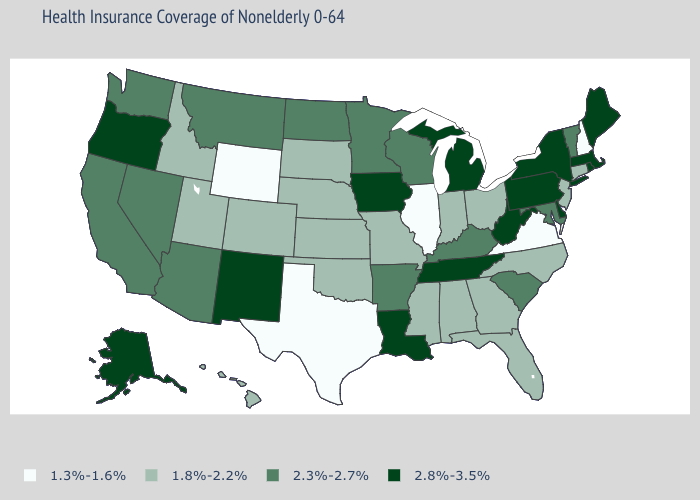Does the first symbol in the legend represent the smallest category?
Short answer required. Yes. What is the highest value in the South ?
Keep it brief. 2.8%-3.5%. Among the states that border New Hampshire , which have the highest value?
Quick response, please. Maine, Massachusetts. What is the value of Hawaii?
Give a very brief answer. 1.8%-2.2%. Is the legend a continuous bar?
Short answer required. No. Name the states that have a value in the range 2.3%-2.7%?
Be succinct. Arizona, Arkansas, California, Kentucky, Maryland, Minnesota, Montana, Nevada, North Dakota, South Carolina, Vermont, Washington, Wisconsin. Name the states that have a value in the range 2.8%-3.5%?
Concise answer only. Alaska, Delaware, Iowa, Louisiana, Maine, Massachusetts, Michigan, New Mexico, New York, Oregon, Pennsylvania, Rhode Island, Tennessee, West Virginia. Is the legend a continuous bar?
Quick response, please. No. What is the value of Missouri?
Answer briefly. 1.8%-2.2%. Does Utah have a higher value than Wyoming?
Write a very short answer. Yes. Name the states that have a value in the range 2.8%-3.5%?
Quick response, please. Alaska, Delaware, Iowa, Louisiana, Maine, Massachusetts, Michigan, New Mexico, New York, Oregon, Pennsylvania, Rhode Island, Tennessee, West Virginia. Does Nebraska have a lower value than Arkansas?
Give a very brief answer. Yes. Does North Carolina have a lower value than Maine?
Answer briefly. Yes. Name the states that have a value in the range 2.8%-3.5%?
Write a very short answer. Alaska, Delaware, Iowa, Louisiana, Maine, Massachusetts, Michigan, New Mexico, New York, Oregon, Pennsylvania, Rhode Island, Tennessee, West Virginia. Among the states that border Vermont , does New Hampshire have the lowest value?
Quick response, please. Yes. 